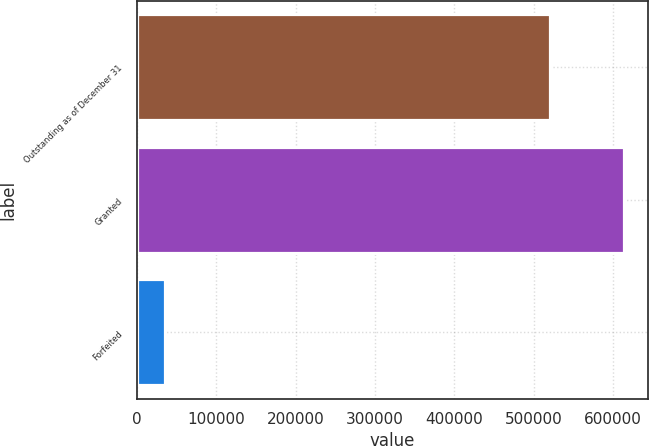Convert chart. <chart><loc_0><loc_0><loc_500><loc_500><bar_chart><fcel>Outstanding as of December 31<fcel>Granted<fcel>Forfeited<nl><fcel>520762<fcel>613570<fcel>35249<nl></chart> 